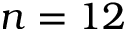Convert formula to latex. <formula><loc_0><loc_0><loc_500><loc_500>n = 1 2</formula> 